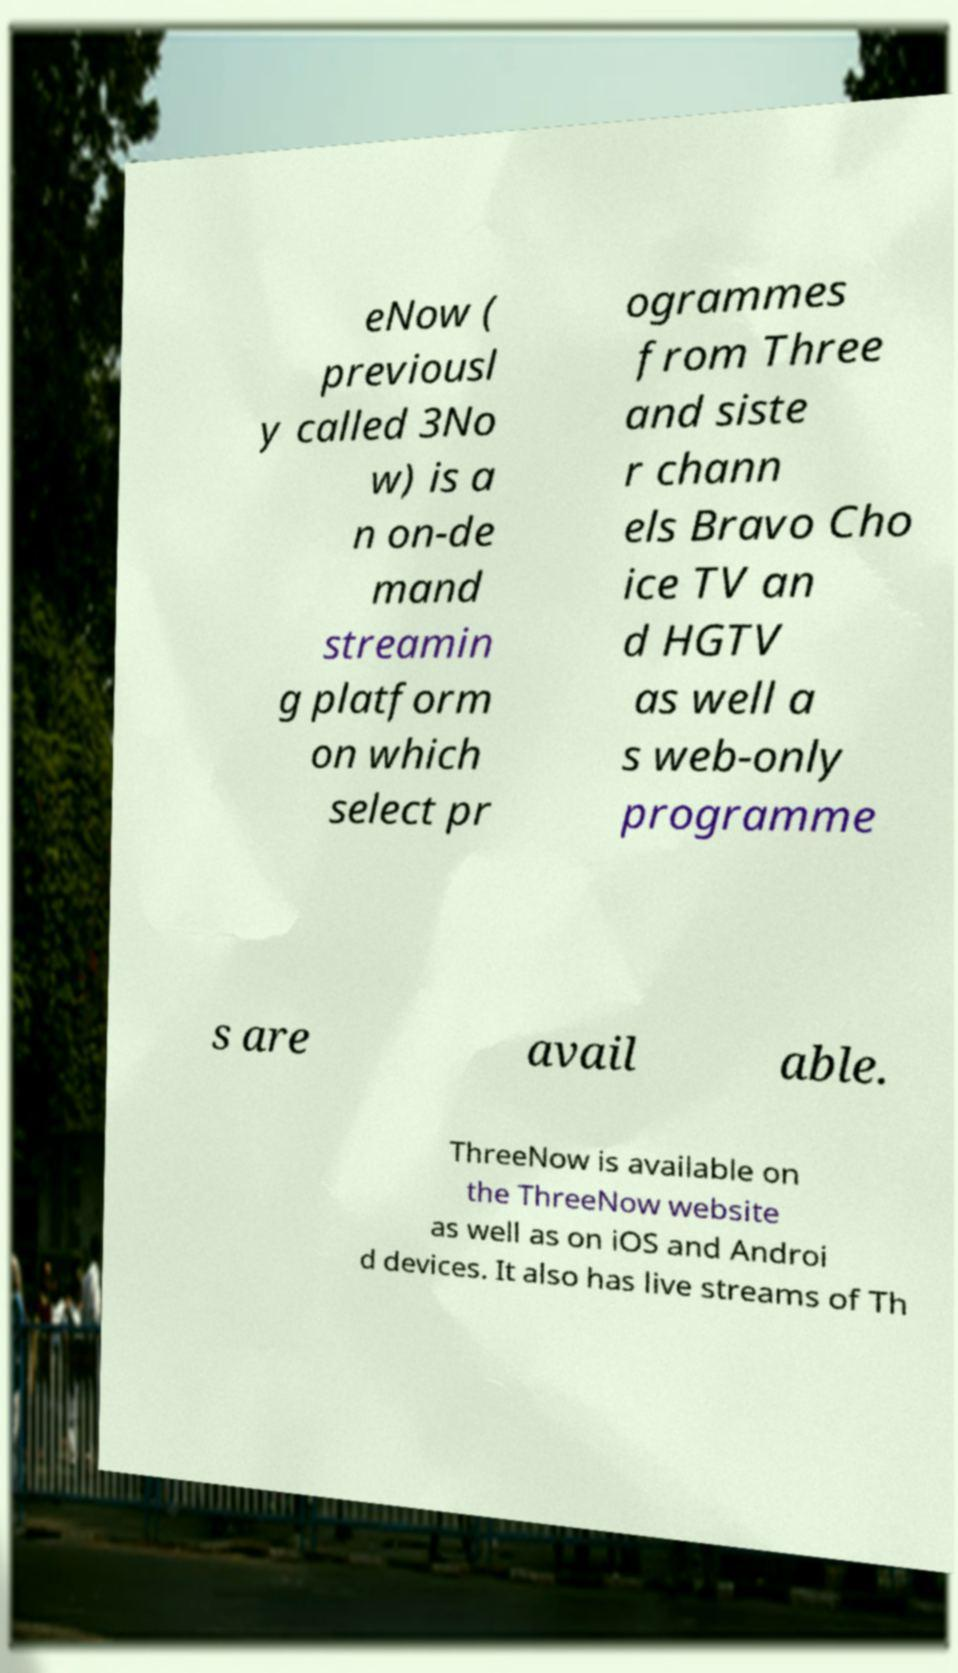Please read and relay the text visible in this image. What does it say? eNow ( previousl y called 3No w) is a n on-de mand streamin g platform on which select pr ogrammes from Three and siste r chann els Bravo Cho ice TV an d HGTV as well a s web-only programme s are avail able. ThreeNow is available on the ThreeNow website as well as on iOS and Androi d devices. It also has live streams of Th 